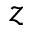Convert formula to latex. <formula><loc_0><loc_0><loc_500><loc_500>z</formula> 